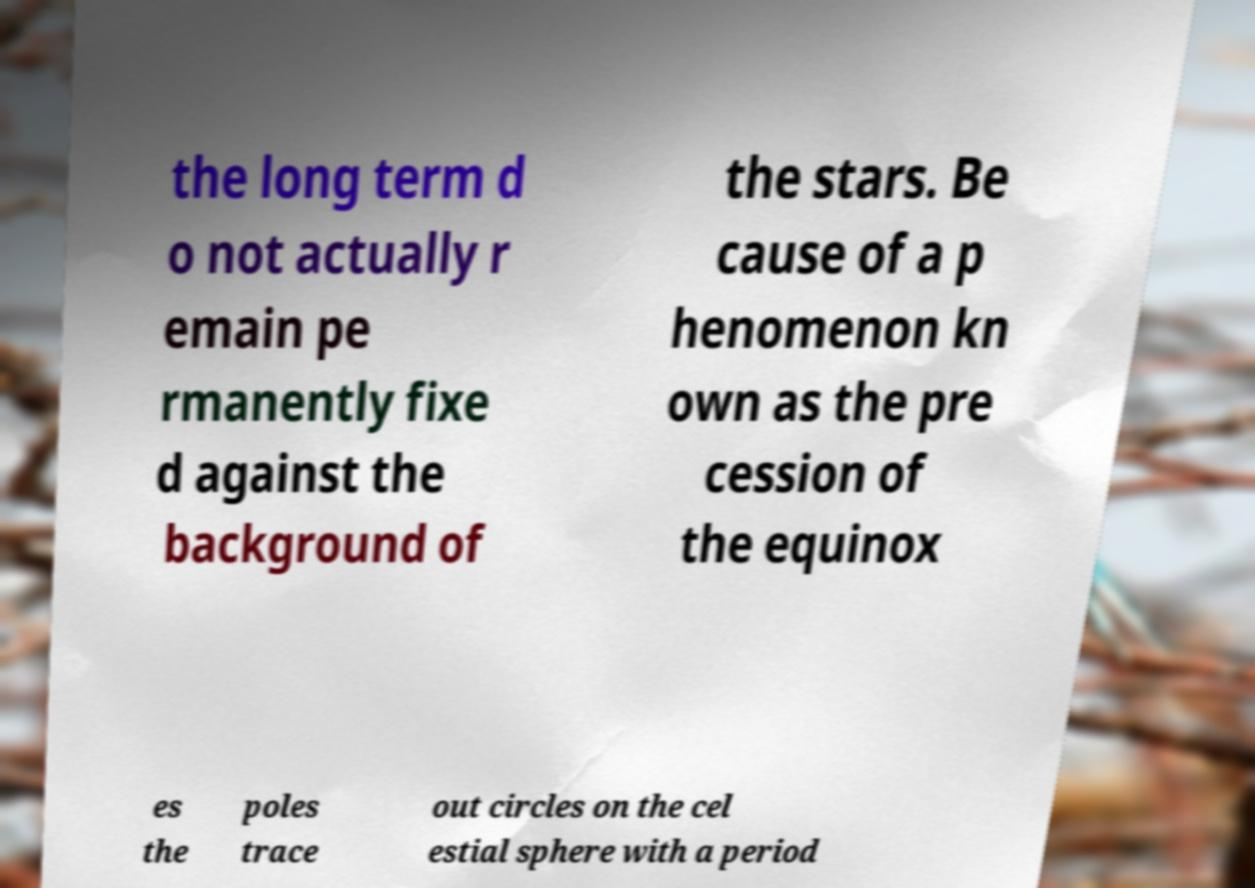Please identify and transcribe the text found in this image. the long term d o not actually r emain pe rmanently fixe d against the background of the stars. Be cause of a p henomenon kn own as the pre cession of the equinox es the poles trace out circles on the cel estial sphere with a period 